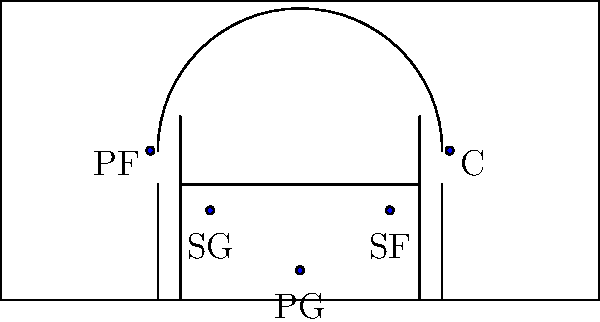In the 1-2-2 offensive formation shown in the diagram, which player is typically responsible for initiating the offense and is positioned at the top of the key? To answer this question, let's break down the 1-2-2 offensive formation in women's basketball:

1. The formation consists of five players on the court.
2. In the diagram, we can see the players arranged in a specific pattern:
   - One player at the top of the key
   - Two players positioned slightly lower, on either side
   - Two players positioned near the baseline, on opposite sides of the court
3. The player positions are labeled in the diagram:
   - PG (Point Guard) at the top of the key
   - SG (Shooting Guard) and SF (Small Forward) in the middle
   - PF (Power Forward) and C (Center) near the baseline
4. In basketball, the Point Guard is typically responsible for initiating the offense and controlling the flow of the game.
5. The PG is positioned at the top of the key in this formation, which allows them to have a clear view of the court and make decisions about passing or driving to the basket.

Therefore, based on the diagram and typical basketball roles, the player responsible for initiating the offense and positioned at the top of the key is the Point Guard (PG).
Answer: Point Guard (PG) 